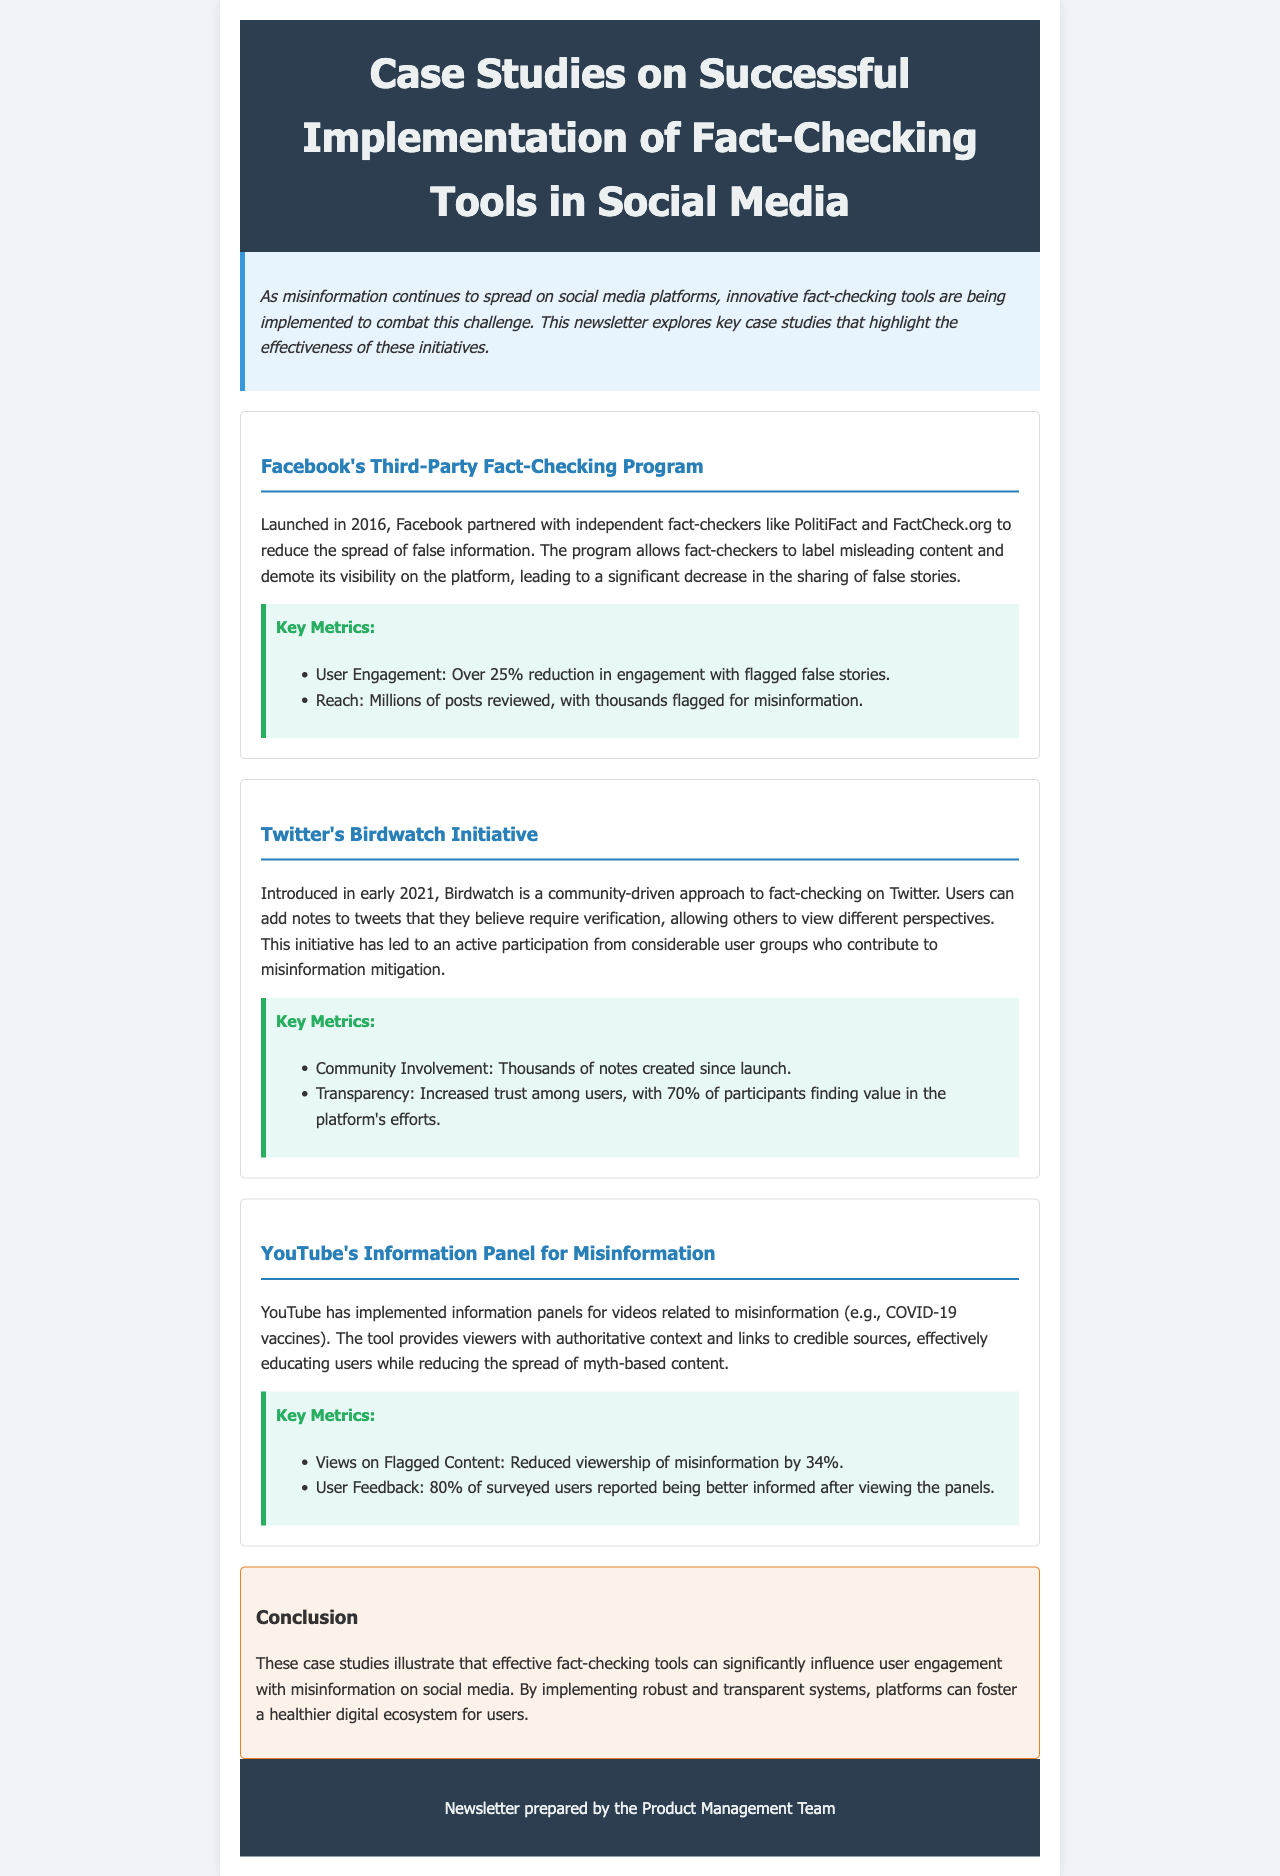What year was Facebook's Third-Party Fact-Checking Program launched? The document states that Facebook's program was launched in 2016.
Answer: 2016 What was the reduction in engagement with flagged false stories on Facebook? The document mentions a 25% reduction in user engagement with flagged false stories.
Answer: 25% What initiative did Twitter introduce in early 2021? The document refers to Twitter's Birdwatch initiative which was introduced in early 2021.
Answer: Birdwatch What percentage of participants found value in Twitter's Birdwatch initiative? According to the document, 70% of participants found value in Twitter's Birdwatch initiative.
Answer: 70% By what percentage did YouTube reduce viewership of misinformation? The document states that YouTube reduced the viewership of misinformation by 34%.
Answer: 34% What educational aspect did YouTube's Information Panel provide? The document indicates that YouTube's tool provided viewers with authoritative context and links to credible sources.
Answer: Authoritative context What effect did Facebook's fact-checking initiatives have on the sharing of false stories? The document explains that Facebook's program resulted in a significant decrease in the sharing of false stories.
Answer: Significant decrease What is the primary goal of the newsletter? The document describes the goal of the newsletter as highlighting the effectiveness of fact-checking tools in combating misinformation.
Answer: Highlighting effectiveness What aspect of community involvement does Twitter's Birdwatch focus on? The document states that Birdwatch allows users to add notes to tweets, showcasing community-driven participation.
Answer: Community-driven participation 